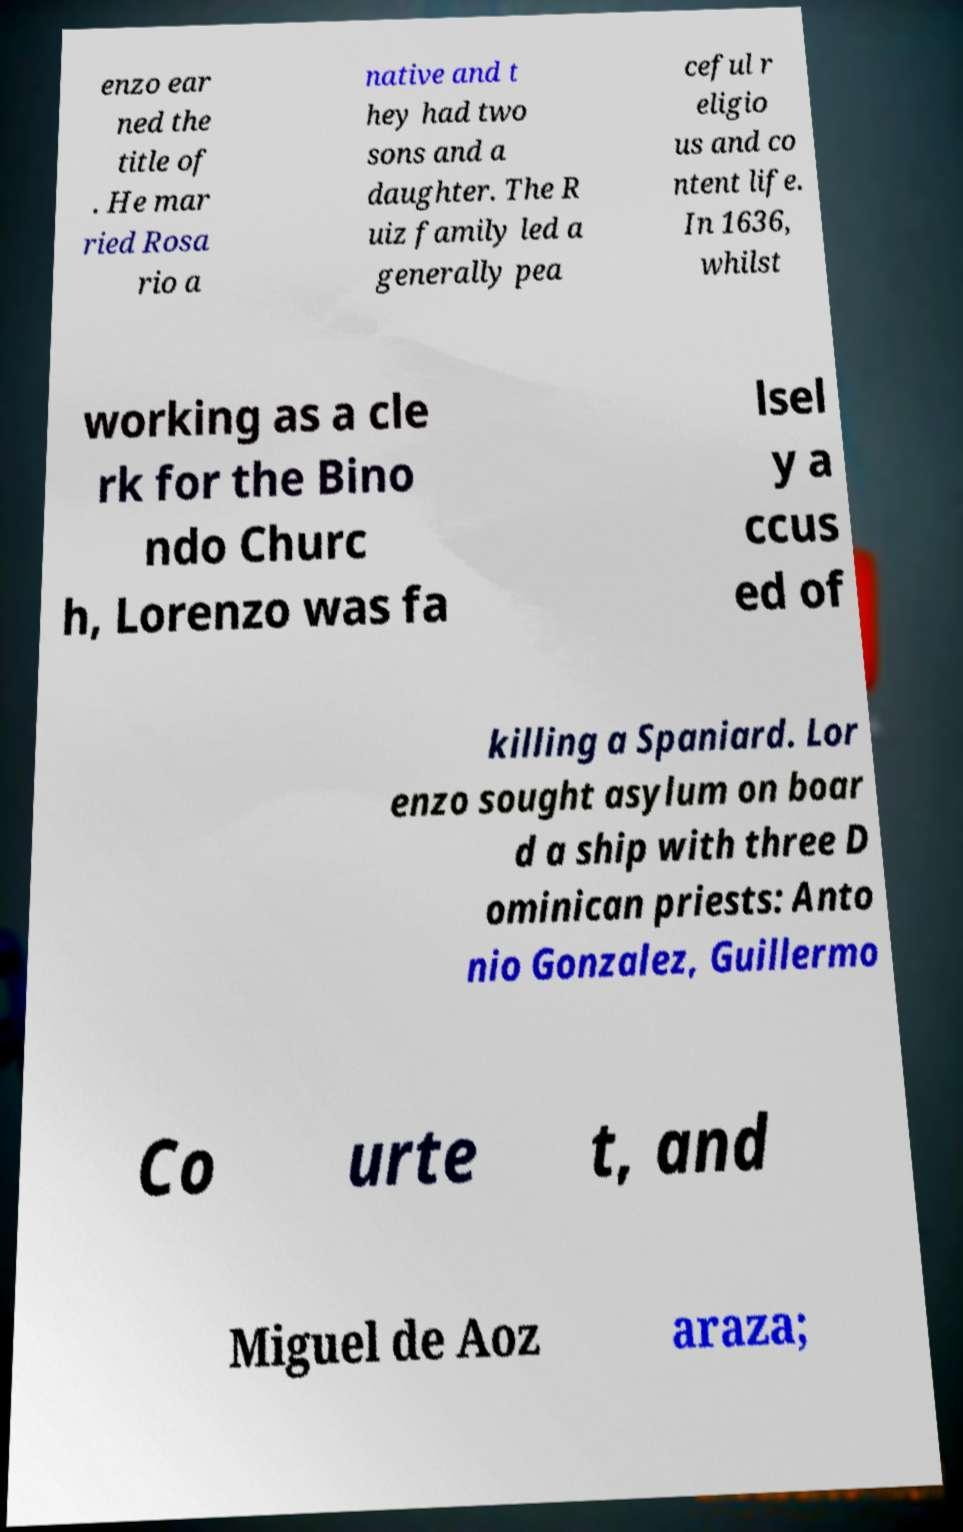Can you accurately transcribe the text from the provided image for me? enzo ear ned the title of . He mar ried Rosa rio a native and t hey had two sons and a daughter. The R uiz family led a generally pea ceful r eligio us and co ntent life. In 1636, whilst working as a cle rk for the Bino ndo Churc h, Lorenzo was fa lsel y a ccus ed of killing a Spaniard. Lor enzo sought asylum on boar d a ship with three D ominican priests: Anto nio Gonzalez, Guillermo Co urte t, and Miguel de Aoz araza; 